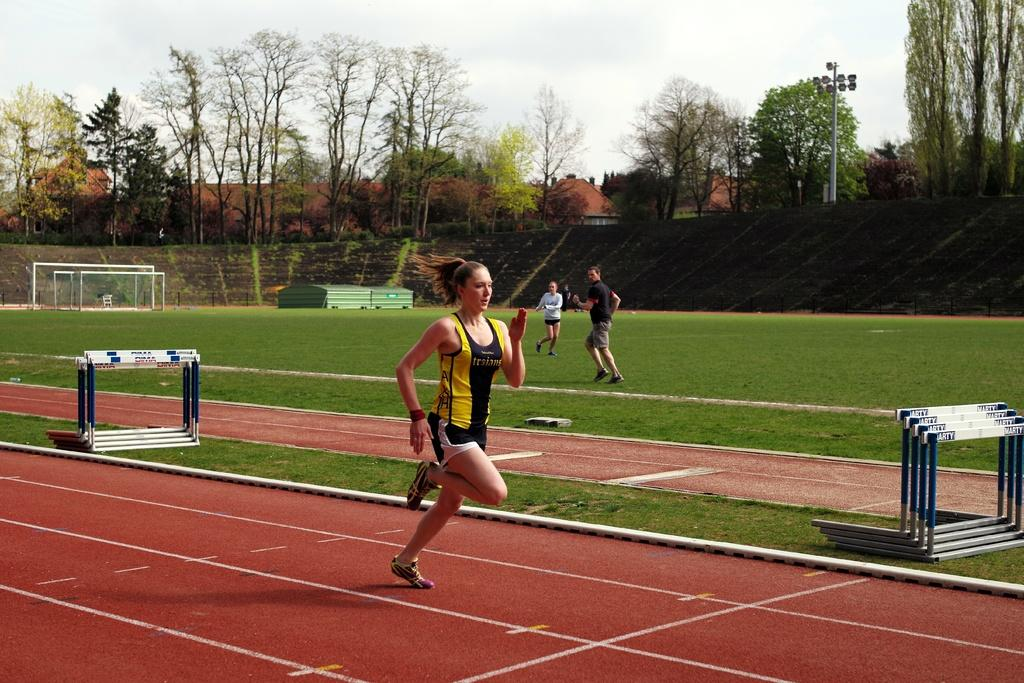What is the woman in the image doing? The woman is running on the ground. What is the surface of the ground in the image? The ground is covered with grass. Are there any other people in the image besides the woman running? Yes, there are people present in the image. What objects can be seen in the image related to sports or athletics? There is a mesh and a pole in the image. What type of display devices are present in the image? There are screens in the image. How many pigs are visible on the ground in the image? There are no pigs present in the image; the ground is covered with grass and the woman is running on it. What is the condition of the woman's toe in the image? There is no information about the woman's toe in the image, as the focus is on her running and the surrounding environment. 